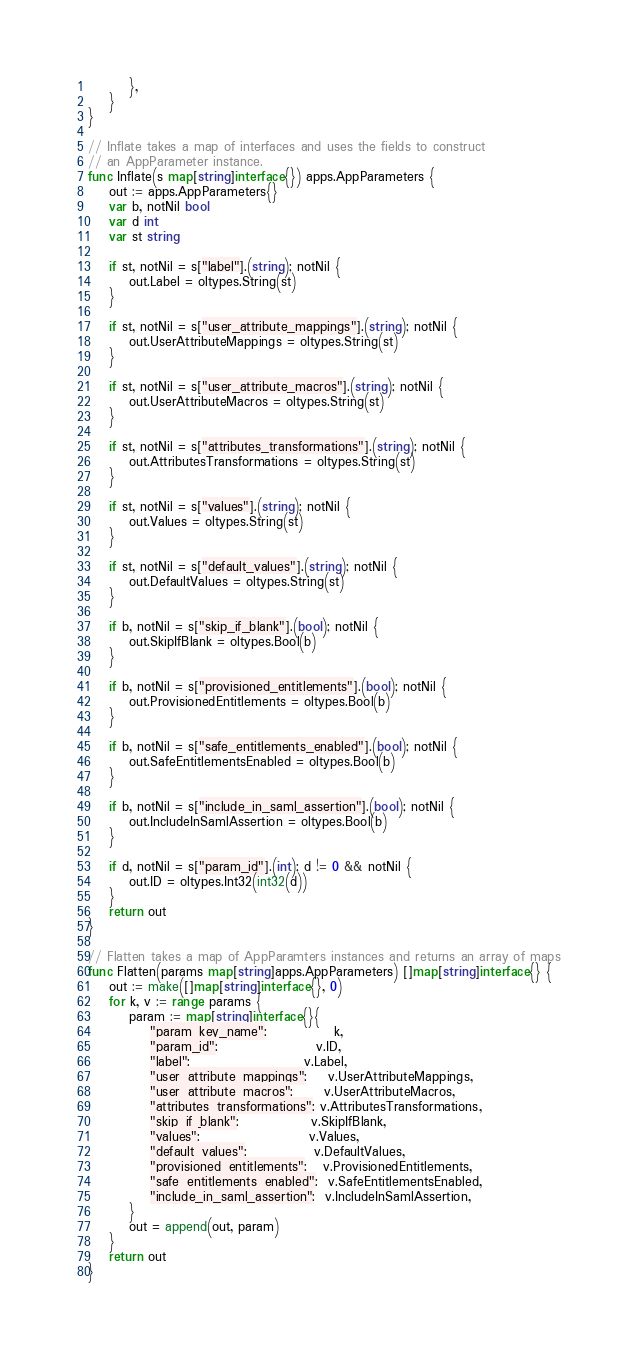<code> <loc_0><loc_0><loc_500><loc_500><_Go_>		},
	}
}

// Inflate takes a map of interfaces and uses the fields to construct
// an AppParameter instance.
func Inflate(s map[string]interface{}) apps.AppParameters {
	out := apps.AppParameters{}
	var b, notNil bool
	var d int
	var st string

	if st, notNil = s["label"].(string); notNil {
		out.Label = oltypes.String(st)
	}

	if st, notNil = s["user_attribute_mappings"].(string); notNil {
		out.UserAttributeMappings = oltypes.String(st)
	}

	if st, notNil = s["user_attribute_macros"].(string); notNil {
		out.UserAttributeMacros = oltypes.String(st)
	}

	if st, notNil = s["attributes_transformations"].(string); notNil {
		out.AttributesTransformations = oltypes.String(st)
	}

	if st, notNil = s["values"].(string); notNil {
		out.Values = oltypes.String(st)
	}

	if st, notNil = s["default_values"].(string); notNil {
		out.DefaultValues = oltypes.String(st)
	}

	if b, notNil = s["skip_if_blank"].(bool); notNil {
		out.SkipIfBlank = oltypes.Bool(b)
	}

	if b, notNil = s["provisioned_entitlements"].(bool); notNil {
		out.ProvisionedEntitlements = oltypes.Bool(b)
	}

	if b, notNil = s["safe_entitlements_enabled"].(bool); notNil {
		out.SafeEntitlementsEnabled = oltypes.Bool(b)
	}

	if b, notNil = s["include_in_saml_assertion"].(bool); notNil {
		out.IncludeInSamlAssertion = oltypes.Bool(b)
	}

	if d, notNil = s["param_id"].(int); d != 0 && notNil {
		out.ID = oltypes.Int32(int32(d))
	}
	return out
}

// Flatten takes a map of AppParamters instances and returns an array of maps
func Flatten(params map[string]apps.AppParameters) []map[string]interface{} {
	out := make([]map[string]interface{}, 0)
	for k, v := range params {
		param := map[string]interface{}{
			"param_key_name":             k,
			"param_id":                   v.ID,
			"label":                      v.Label,
			"user_attribute_mappings":    v.UserAttributeMappings,
			"user_attribute_macros":      v.UserAttributeMacros,
			"attributes_transformations": v.AttributesTransformations,
			"skip_if_blank":              v.SkipIfBlank,
			"values":                     v.Values,
			"default_values":             v.DefaultValues,
			"provisioned_entitlements":   v.ProvisionedEntitlements,
			"safe_entitlements_enabled":  v.SafeEntitlementsEnabled,
			"include_in_saml_assertion":  v.IncludeInSamlAssertion,
		}
		out = append(out, param)
	}
	return out
}
</code> 